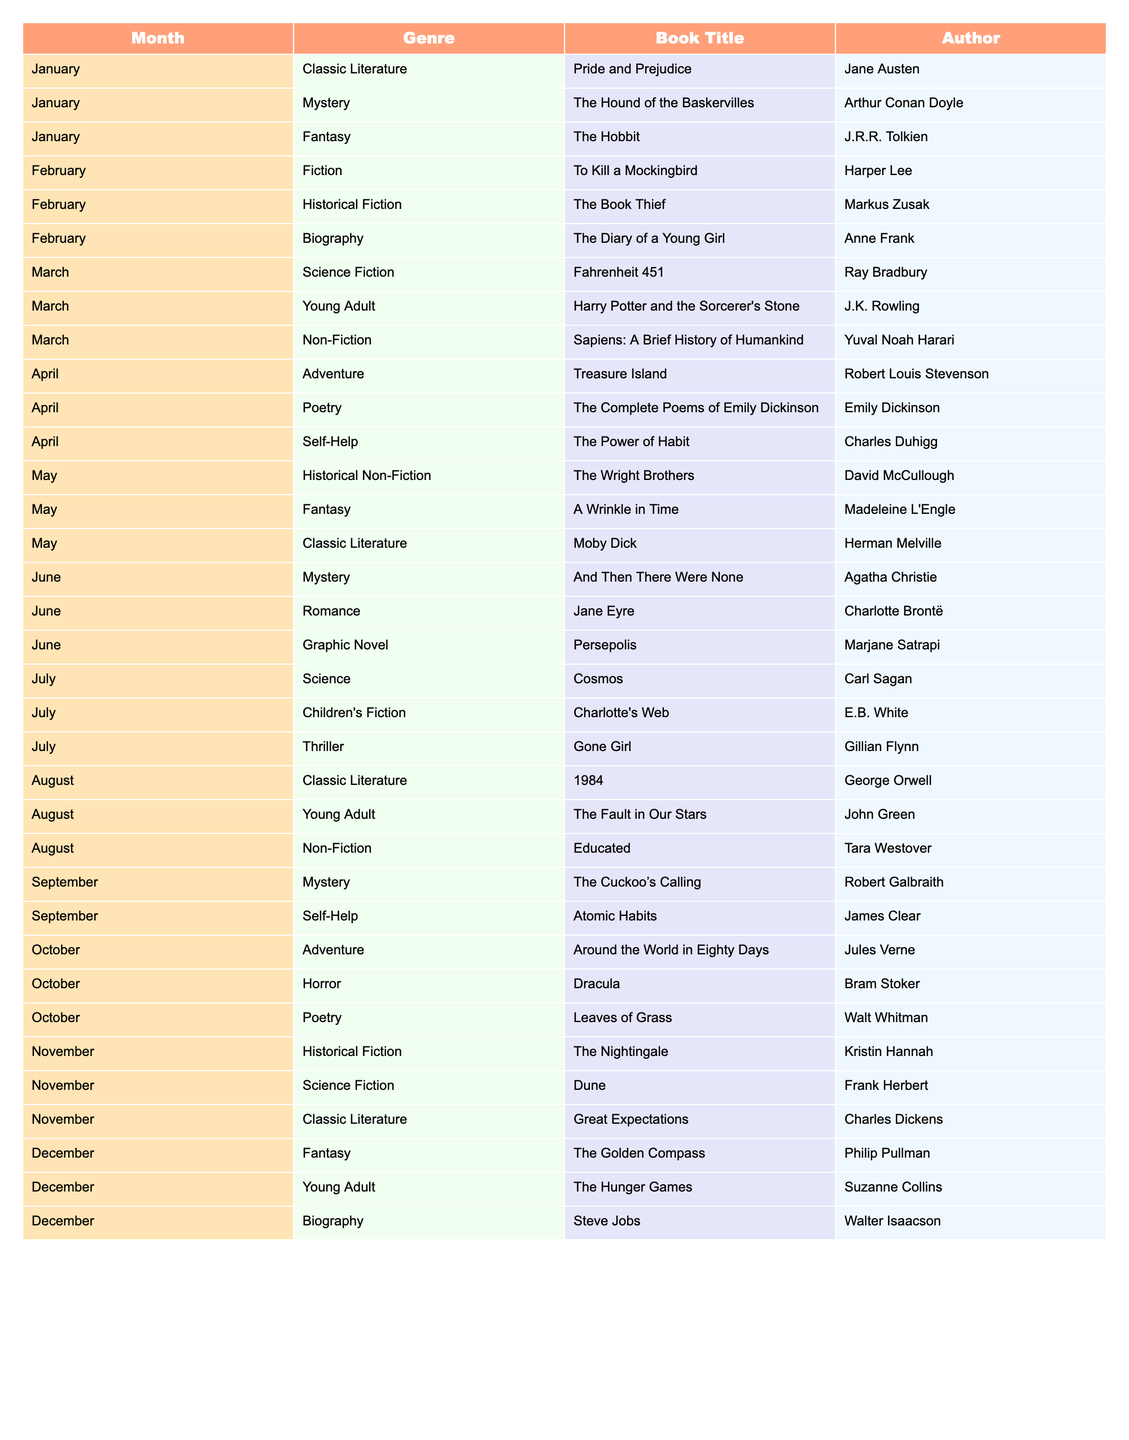What book was read in February from the Biography genre? The table shows that in February, the Biography genre includes “The Diary of a Young Girl” by Anne Frank.
Answer: The Diary of a Young Girl Which month contains the most Science Fiction books? The table indicates that March and November both contain one Science Fiction book each; therefore, no month has more than one.
Answer: No month has more than one Is "Jane Eyre" a book classified under Romance? According to the table, "Jane Eyre" is listed under the Romance genre, confirming it yes.
Answer: Yes How many Classic Literature books are read throughout the year? Looking at the table, Classic Literature appears in January, May, August, and November with four entries total.
Answer: Four In which month did the Children’s Fiction book "Charlotte's Web" appear? The table states that "Charlotte's Web" was read in July, making it easy to identify.
Answer: July What is the total number of books listed for the month of April? The table shows three books listed for April: "Treasure Island," "The Complete Poems of Emily Dickinson," and "The Power of Habit," giving a total of three.
Answer: Three Which genre has the least representation in the reading list? By comparing the genres, several have only one entry, such as Self-Help, Adventure, and Horror among others, indicating multiple with one title.
Answer: Multiple genres have one book How many Unique authors are present in the entire reading list? By listing all the authors from the table: Jane Austen, Arthur Conan Doyle, J.R.R. Tolkien, etc., there are a total of 24 unique authors.
Answer: Twenty-four Which month features a book in both Adventure and Horror genres? Upon checking the table, October includes "Around the World in Eighty Days" (Adventure) and "Dracula" (Horror), confirming the presence of both genres in that month.
Answer: October Which book has the latest release date by author if considering publication history? If considering publication history, "Educated" by Tara Westover is the most recently published book in the table, since it was released in 2018.
Answer: Educated 